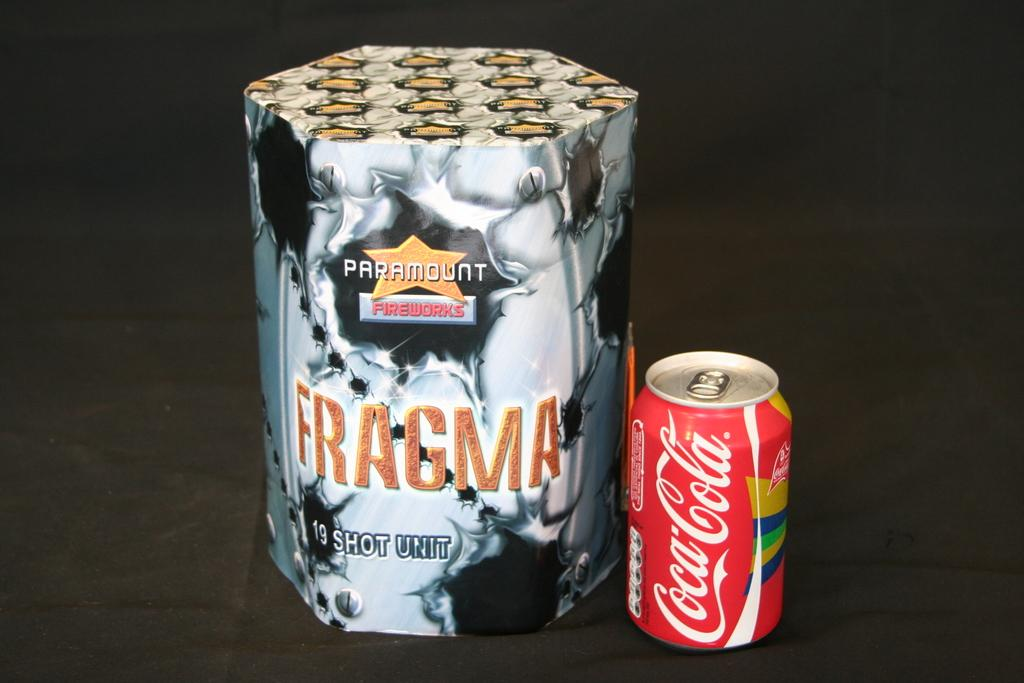Provide a one-sentence caption for the provided image. A red tin of coca cola sits beside another object with the word Fragma written on it,. 